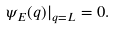Convert formula to latex. <formula><loc_0><loc_0><loc_500><loc_500>\psi _ { E } ( q ) | _ { q = L } = 0 .</formula> 